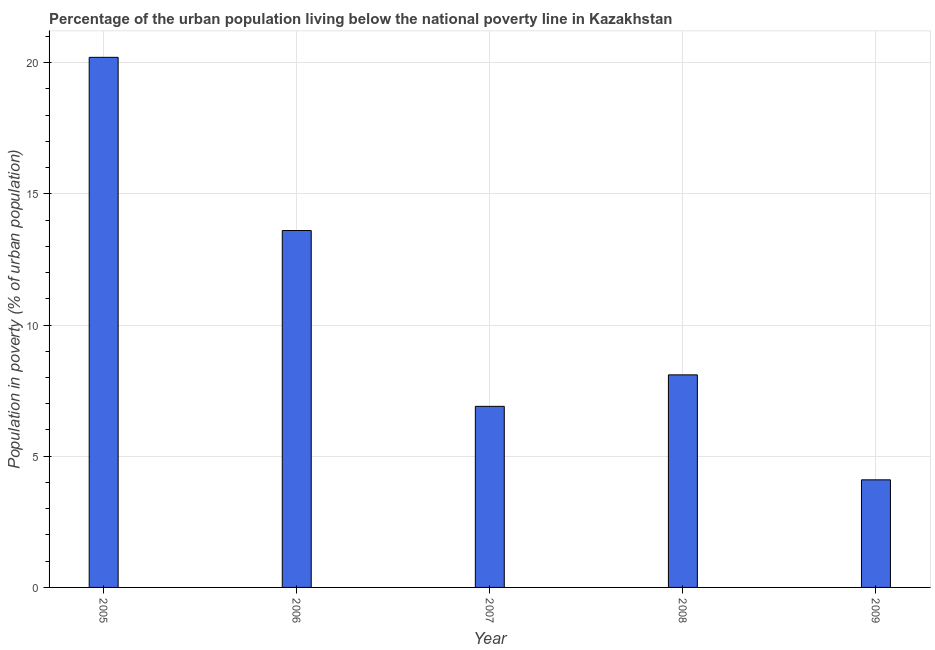Does the graph contain any zero values?
Ensure brevity in your answer.  No. What is the title of the graph?
Provide a succinct answer. Percentage of the urban population living below the national poverty line in Kazakhstan. What is the label or title of the X-axis?
Offer a terse response. Year. What is the label or title of the Y-axis?
Give a very brief answer. Population in poverty (% of urban population). Across all years, what is the maximum percentage of urban population living below poverty line?
Offer a very short reply. 20.2. Across all years, what is the minimum percentage of urban population living below poverty line?
Provide a succinct answer. 4.1. In which year was the percentage of urban population living below poverty line minimum?
Your answer should be very brief. 2009. What is the sum of the percentage of urban population living below poverty line?
Your answer should be very brief. 52.9. What is the difference between the percentage of urban population living below poverty line in 2006 and 2009?
Your answer should be very brief. 9.5. What is the average percentage of urban population living below poverty line per year?
Provide a succinct answer. 10.58. In how many years, is the percentage of urban population living below poverty line greater than 1 %?
Provide a short and direct response. 5. Do a majority of the years between 2008 and 2006 (inclusive) have percentage of urban population living below poverty line greater than 9 %?
Give a very brief answer. Yes. What is the ratio of the percentage of urban population living below poverty line in 2007 to that in 2009?
Offer a terse response. 1.68. How many years are there in the graph?
Your answer should be very brief. 5. Are the values on the major ticks of Y-axis written in scientific E-notation?
Your answer should be compact. No. What is the Population in poverty (% of urban population) of 2005?
Provide a short and direct response. 20.2. What is the Population in poverty (% of urban population) in 2009?
Your answer should be compact. 4.1. What is the difference between the Population in poverty (% of urban population) in 2005 and 2006?
Ensure brevity in your answer.  6.6. What is the difference between the Population in poverty (% of urban population) in 2006 and 2007?
Your response must be concise. 6.7. What is the difference between the Population in poverty (% of urban population) in 2006 and 2009?
Offer a terse response. 9.5. What is the ratio of the Population in poverty (% of urban population) in 2005 to that in 2006?
Give a very brief answer. 1.49. What is the ratio of the Population in poverty (% of urban population) in 2005 to that in 2007?
Give a very brief answer. 2.93. What is the ratio of the Population in poverty (% of urban population) in 2005 to that in 2008?
Provide a succinct answer. 2.49. What is the ratio of the Population in poverty (% of urban population) in 2005 to that in 2009?
Offer a very short reply. 4.93. What is the ratio of the Population in poverty (% of urban population) in 2006 to that in 2007?
Keep it short and to the point. 1.97. What is the ratio of the Population in poverty (% of urban population) in 2006 to that in 2008?
Make the answer very short. 1.68. What is the ratio of the Population in poverty (% of urban population) in 2006 to that in 2009?
Make the answer very short. 3.32. What is the ratio of the Population in poverty (% of urban population) in 2007 to that in 2008?
Provide a succinct answer. 0.85. What is the ratio of the Population in poverty (% of urban population) in 2007 to that in 2009?
Provide a short and direct response. 1.68. What is the ratio of the Population in poverty (% of urban population) in 2008 to that in 2009?
Provide a short and direct response. 1.98. 